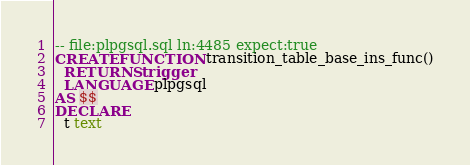<code> <loc_0><loc_0><loc_500><loc_500><_SQL_>-- file:plpgsql.sql ln:4485 expect:true
CREATE FUNCTION transition_table_base_ins_func()
  RETURNS trigger
  LANGUAGE plpgsql
AS $$
DECLARE
  t text
</code> 